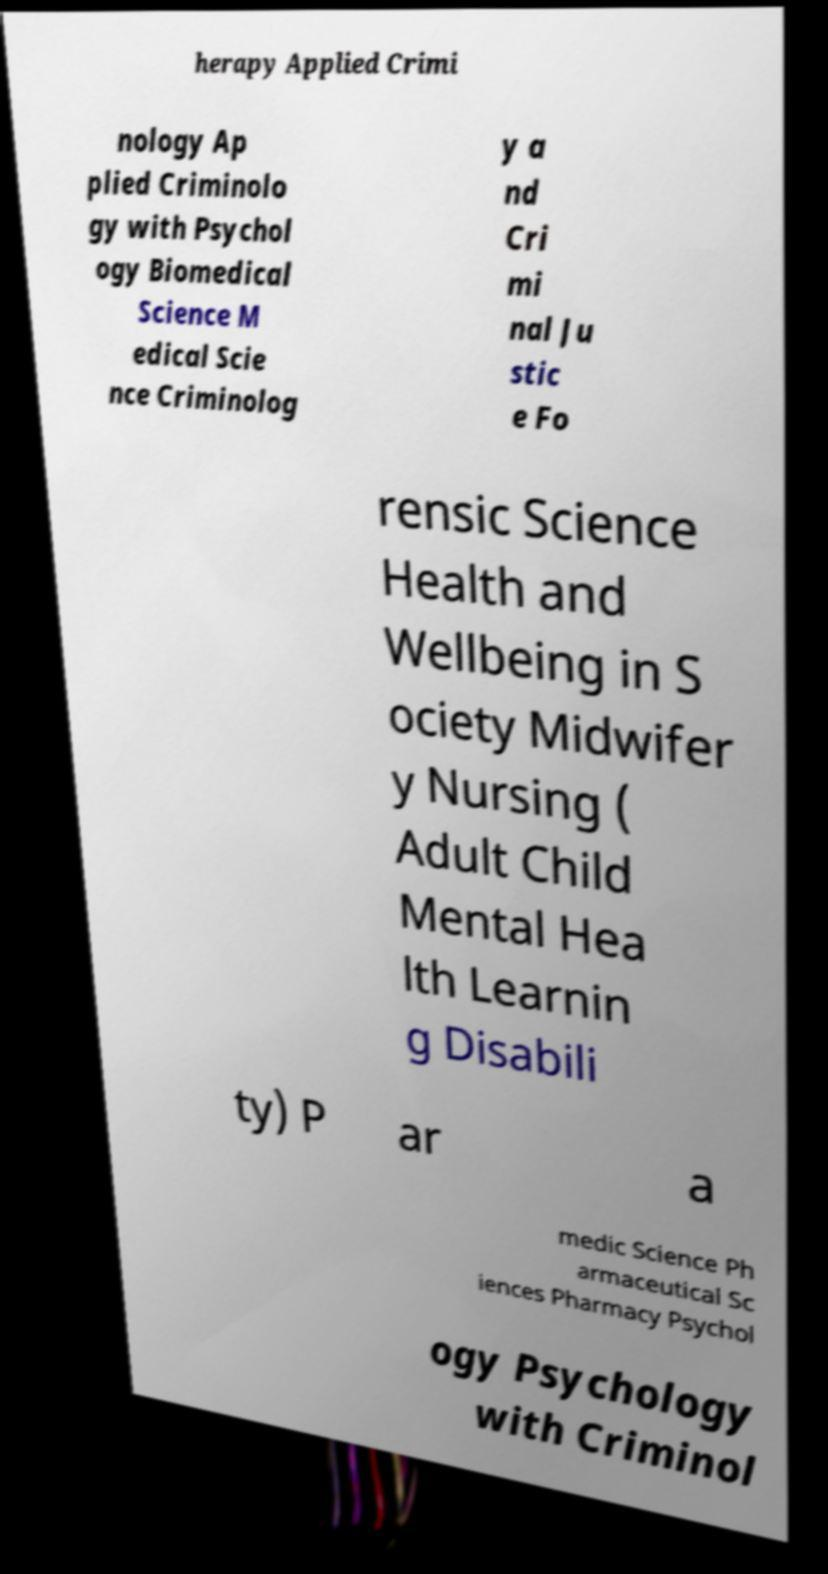I need the written content from this picture converted into text. Can you do that? herapy Applied Crimi nology Ap plied Criminolo gy with Psychol ogy Biomedical Science M edical Scie nce Criminolog y a nd Cri mi nal Ju stic e Fo rensic Science Health and Wellbeing in S ociety Midwifer y Nursing ( Adult Child Mental Hea lth Learnin g Disabili ty) P ar a medic Science Ph armaceutical Sc iences Pharmacy Psychol ogy Psychology with Criminol 